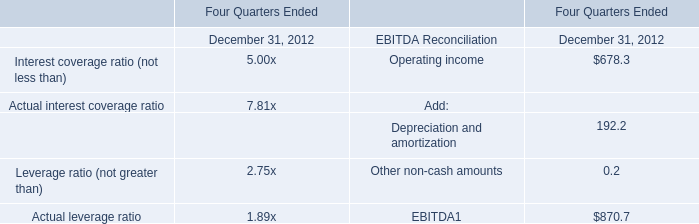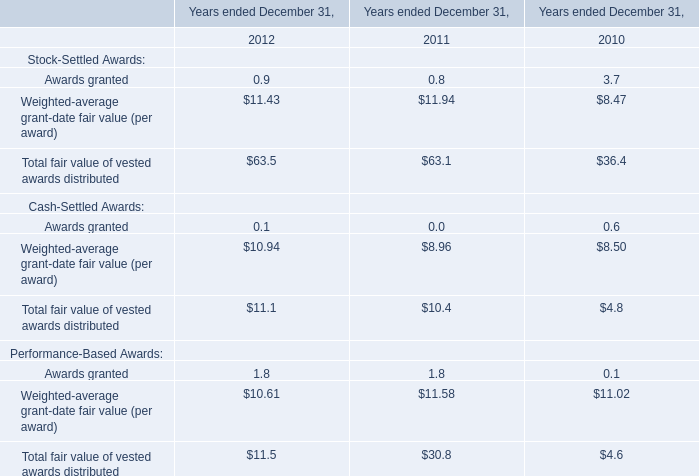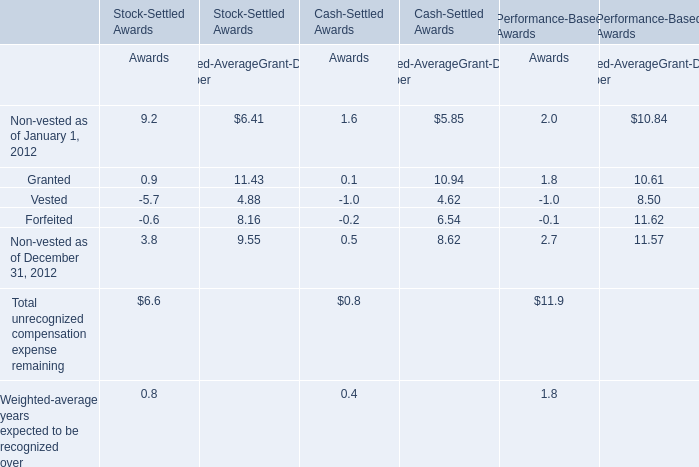What is the total value of Awards granted, Weighted-average grant-date fair value (per award), Total fair value of vested awards distributed and Awards granted in 2011? 
Computations: (((8.96 + 10.4) + 1.8) + 0)
Answer: 21.16. 